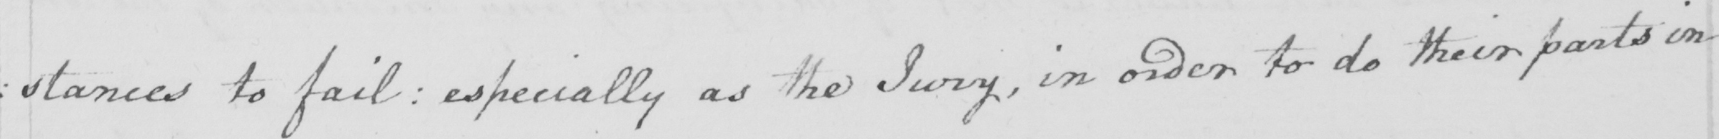What is written in this line of handwriting? : stances to fail :  especially as the Jury , in order to do their parts in 